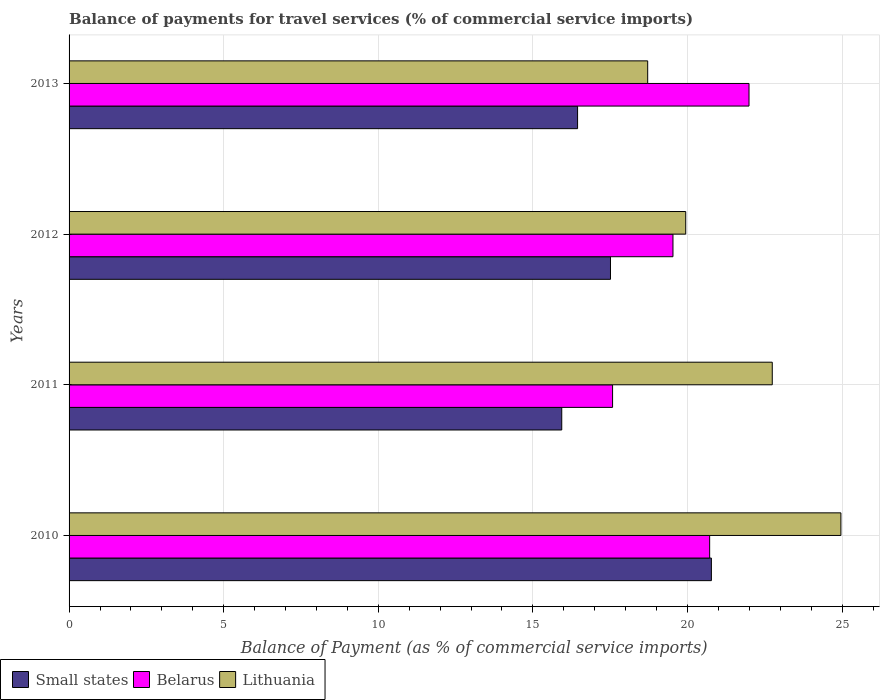How many different coloured bars are there?
Provide a short and direct response. 3. How many groups of bars are there?
Provide a succinct answer. 4. Are the number of bars on each tick of the Y-axis equal?
Provide a succinct answer. Yes. How many bars are there on the 4th tick from the bottom?
Your response must be concise. 3. What is the balance of payments for travel services in Lithuania in 2013?
Your answer should be very brief. 18.71. Across all years, what is the maximum balance of payments for travel services in Lithuania?
Ensure brevity in your answer.  24.96. Across all years, what is the minimum balance of payments for travel services in Belarus?
Ensure brevity in your answer.  17.58. What is the total balance of payments for travel services in Lithuania in the graph?
Provide a succinct answer. 86.36. What is the difference between the balance of payments for travel services in Small states in 2010 and that in 2013?
Your answer should be very brief. 4.33. What is the difference between the balance of payments for travel services in Small states in 2010 and the balance of payments for travel services in Lithuania in 2012?
Keep it short and to the point. 0.83. What is the average balance of payments for travel services in Small states per year?
Your answer should be compact. 17.66. In the year 2012, what is the difference between the balance of payments for travel services in Lithuania and balance of payments for travel services in Small states?
Offer a very short reply. 2.43. What is the ratio of the balance of payments for travel services in Lithuania in 2010 to that in 2012?
Your answer should be compact. 1.25. What is the difference between the highest and the second highest balance of payments for travel services in Lithuania?
Provide a succinct answer. 2.22. What is the difference between the highest and the lowest balance of payments for travel services in Lithuania?
Your response must be concise. 6.25. Is the sum of the balance of payments for travel services in Small states in 2010 and 2013 greater than the maximum balance of payments for travel services in Belarus across all years?
Your response must be concise. Yes. What does the 1st bar from the top in 2011 represents?
Ensure brevity in your answer.  Lithuania. What does the 2nd bar from the bottom in 2010 represents?
Keep it short and to the point. Belarus. Is it the case that in every year, the sum of the balance of payments for travel services in Small states and balance of payments for travel services in Lithuania is greater than the balance of payments for travel services in Belarus?
Offer a very short reply. Yes. How many bars are there?
Ensure brevity in your answer.  12. Are all the bars in the graph horizontal?
Your answer should be compact. Yes. How many years are there in the graph?
Offer a terse response. 4. What is the difference between two consecutive major ticks on the X-axis?
Make the answer very short. 5. Does the graph contain any zero values?
Give a very brief answer. No. How are the legend labels stacked?
Provide a succinct answer. Horizontal. What is the title of the graph?
Ensure brevity in your answer.  Balance of payments for travel services (% of commercial service imports). Does "Paraguay" appear as one of the legend labels in the graph?
Give a very brief answer. No. What is the label or title of the X-axis?
Offer a very short reply. Balance of Payment (as % of commercial service imports). What is the label or title of the Y-axis?
Provide a succinct answer. Years. What is the Balance of Payment (as % of commercial service imports) of Small states in 2010?
Give a very brief answer. 20.77. What is the Balance of Payment (as % of commercial service imports) of Belarus in 2010?
Ensure brevity in your answer.  20.72. What is the Balance of Payment (as % of commercial service imports) of Lithuania in 2010?
Provide a succinct answer. 24.96. What is the Balance of Payment (as % of commercial service imports) of Small states in 2011?
Make the answer very short. 15.93. What is the Balance of Payment (as % of commercial service imports) in Belarus in 2011?
Give a very brief answer. 17.58. What is the Balance of Payment (as % of commercial service imports) of Lithuania in 2011?
Make the answer very short. 22.74. What is the Balance of Payment (as % of commercial service imports) in Small states in 2012?
Offer a terse response. 17.51. What is the Balance of Payment (as % of commercial service imports) of Belarus in 2012?
Provide a succinct answer. 19.53. What is the Balance of Payment (as % of commercial service imports) of Lithuania in 2012?
Your response must be concise. 19.94. What is the Balance of Payment (as % of commercial service imports) of Small states in 2013?
Your response must be concise. 16.44. What is the Balance of Payment (as % of commercial service imports) of Belarus in 2013?
Offer a terse response. 21.99. What is the Balance of Payment (as % of commercial service imports) in Lithuania in 2013?
Give a very brief answer. 18.71. Across all years, what is the maximum Balance of Payment (as % of commercial service imports) of Small states?
Offer a very short reply. 20.77. Across all years, what is the maximum Balance of Payment (as % of commercial service imports) in Belarus?
Ensure brevity in your answer.  21.99. Across all years, what is the maximum Balance of Payment (as % of commercial service imports) of Lithuania?
Offer a terse response. 24.96. Across all years, what is the minimum Balance of Payment (as % of commercial service imports) of Small states?
Provide a short and direct response. 15.93. Across all years, what is the minimum Balance of Payment (as % of commercial service imports) of Belarus?
Your answer should be compact. 17.58. Across all years, what is the minimum Balance of Payment (as % of commercial service imports) of Lithuania?
Provide a short and direct response. 18.71. What is the total Balance of Payment (as % of commercial service imports) in Small states in the graph?
Make the answer very short. 70.66. What is the total Balance of Payment (as % of commercial service imports) in Belarus in the graph?
Offer a terse response. 79.81. What is the total Balance of Payment (as % of commercial service imports) of Lithuania in the graph?
Keep it short and to the point. 86.36. What is the difference between the Balance of Payment (as % of commercial service imports) of Small states in 2010 and that in 2011?
Your answer should be compact. 4.84. What is the difference between the Balance of Payment (as % of commercial service imports) of Belarus in 2010 and that in 2011?
Your response must be concise. 3.14. What is the difference between the Balance of Payment (as % of commercial service imports) of Lithuania in 2010 and that in 2011?
Your response must be concise. 2.22. What is the difference between the Balance of Payment (as % of commercial service imports) of Small states in 2010 and that in 2012?
Provide a short and direct response. 3.26. What is the difference between the Balance of Payment (as % of commercial service imports) of Belarus in 2010 and that in 2012?
Offer a terse response. 1.19. What is the difference between the Balance of Payment (as % of commercial service imports) of Lithuania in 2010 and that in 2012?
Provide a succinct answer. 5.02. What is the difference between the Balance of Payment (as % of commercial service imports) of Small states in 2010 and that in 2013?
Your answer should be very brief. 4.33. What is the difference between the Balance of Payment (as % of commercial service imports) of Belarus in 2010 and that in 2013?
Make the answer very short. -1.27. What is the difference between the Balance of Payment (as % of commercial service imports) of Lithuania in 2010 and that in 2013?
Your answer should be compact. 6.25. What is the difference between the Balance of Payment (as % of commercial service imports) in Small states in 2011 and that in 2012?
Keep it short and to the point. -1.58. What is the difference between the Balance of Payment (as % of commercial service imports) of Belarus in 2011 and that in 2012?
Make the answer very short. -1.95. What is the difference between the Balance of Payment (as % of commercial service imports) in Lithuania in 2011 and that in 2012?
Your response must be concise. 2.8. What is the difference between the Balance of Payment (as % of commercial service imports) in Small states in 2011 and that in 2013?
Make the answer very short. -0.51. What is the difference between the Balance of Payment (as % of commercial service imports) in Belarus in 2011 and that in 2013?
Keep it short and to the point. -4.41. What is the difference between the Balance of Payment (as % of commercial service imports) of Lithuania in 2011 and that in 2013?
Make the answer very short. 4.03. What is the difference between the Balance of Payment (as % of commercial service imports) of Small states in 2012 and that in 2013?
Ensure brevity in your answer.  1.06. What is the difference between the Balance of Payment (as % of commercial service imports) of Belarus in 2012 and that in 2013?
Ensure brevity in your answer.  -2.46. What is the difference between the Balance of Payment (as % of commercial service imports) of Lithuania in 2012 and that in 2013?
Your answer should be compact. 1.23. What is the difference between the Balance of Payment (as % of commercial service imports) of Small states in 2010 and the Balance of Payment (as % of commercial service imports) of Belarus in 2011?
Offer a terse response. 3.2. What is the difference between the Balance of Payment (as % of commercial service imports) of Small states in 2010 and the Balance of Payment (as % of commercial service imports) of Lithuania in 2011?
Provide a short and direct response. -1.97. What is the difference between the Balance of Payment (as % of commercial service imports) in Belarus in 2010 and the Balance of Payment (as % of commercial service imports) in Lithuania in 2011?
Ensure brevity in your answer.  -2.02. What is the difference between the Balance of Payment (as % of commercial service imports) of Small states in 2010 and the Balance of Payment (as % of commercial service imports) of Belarus in 2012?
Provide a short and direct response. 1.24. What is the difference between the Balance of Payment (as % of commercial service imports) in Small states in 2010 and the Balance of Payment (as % of commercial service imports) in Lithuania in 2012?
Give a very brief answer. 0.83. What is the difference between the Balance of Payment (as % of commercial service imports) of Belarus in 2010 and the Balance of Payment (as % of commercial service imports) of Lithuania in 2012?
Keep it short and to the point. 0.77. What is the difference between the Balance of Payment (as % of commercial service imports) of Small states in 2010 and the Balance of Payment (as % of commercial service imports) of Belarus in 2013?
Make the answer very short. -1.22. What is the difference between the Balance of Payment (as % of commercial service imports) of Small states in 2010 and the Balance of Payment (as % of commercial service imports) of Lithuania in 2013?
Make the answer very short. 2.06. What is the difference between the Balance of Payment (as % of commercial service imports) of Belarus in 2010 and the Balance of Payment (as % of commercial service imports) of Lithuania in 2013?
Offer a terse response. 2. What is the difference between the Balance of Payment (as % of commercial service imports) in Small states in 2011 and the Balance of Payment (as % of commercial service imports) in Belarus in 2012?
Your answer should be very brief. -3.6. What is the difference between the Balance of Payment (as % of commercial service imports) in Small states in 2011 and the Balance of Payment (as % of commercial service imports) in Lithuania in 2012?
Make the answer very short. -4.01. What is the difference between the Balance of Payment (as % of commercial service imports) of Belarus in 2011 and the Balance of Payment (as % of commercial service imports) of Lithuania in 2012?
Your answer should be very brief. -2.37. What is the difference between the Balance of Payment (as % of commercial service imports) in Small states in 2011 and the Balance of Payment (as % of commercial service imports) in Belarus in 2013?
Provide a succinct answer. -6.06. What is the difference between the Balance of Payment (as % of commercial service imports) in Small states in 2011 and the Balance of Payment (as % of commercial service imports) in Lithuania in 2013?
Make the answer very short. -2.78. What is the difference between the Balance of Payment (as % of commercial service imports) in Belarus in 2011 and the Balance of Payment (as % of commercial service imports) in Lithuania in 2013?
Offer a very short reply. -1.14. What is the difference between the Balance of Payment (as % of commercial service imports) of Small states in 2012 and the Balance of Payment (as % of commercial service imports) of Belarus in 2013?
Provide a succinct answer. -4.48. What is the difference between the Balance of Payment (as % of commercial service imports) of Small states in 2012 and the Balance of Payment (as % of commercial service imports) of Lithuania in 2013?
Give a very brief answer. -1.2. What is the difference between the Balance of Payment (as % of commercial service imports) of Belarus in 2012 and the Balance of Payment (as % of commercial service imports) of Lithuania in 2013?
Offer a very short reply. 0.82. What is the average Balance of Payment (as % of commercial service imports) of Small states per year?
Your answer should be compact. 17.66. What is the average Balance of Payment (as % of commercial service imports) in Belarus per year?
Ensure brevity in your answer.  19.95. What is the average Balance of Payment (as % of commercial service imports) in Lithuania per year?
Your answer should be very brief. 21.59. In the year 2010, what is the difference between the Balance of Payment (as % of commercial service imports) in Small states and Balance of Payment (as % of commercial service imports) in Belarus?
Your answer should be compact. 0.06. In the year 2010, what is the difference between the Balance of Payment (as % of commercial service imports) in Small states and Balance of Payment (as % of commercial service imports) in Lithuania?
Keep it short and to the point. -4.19. In the year 2010, what is the difference between the Balance of Payment (as % of commercial service imports) in Belarus and Balance of Payment (as % of commercial service imports) in Lithuania?
Your answer should be very brief. -4.24. In the year 2011, what is the difference between the Balance of Payment (as % of commercial service imports) in Small states and Balance of Payment (as % of commercial service imports) in Belarus?
Ensure brevity in your answer.  -1.64. In the year 2011, what is the difference between the Balance of Payment (as % of commercial service imports) of Small states and Balance of Payment (as % of commercial service imports) of Lithuania?
Ensure brevity in your answer.  -6.81. In the year 2011, what is the difference between the Balance of Payment (as % of commercial service imports) in Belarus and Balance of Payment (as % of commercial service imports) in Lithuania?
Provide a short and direct response. -5.16. In the year 2012, what is the difference between the Balance of Payment (as % of commercial service imports) in Small states and Balance of Payment (as % of commercial service imports) in Belarus?
Keep it short and to the point. -2.02. In the year 2012, what is the difference between the Balance of Payment (as % of commercial service imports) of Small states and Balance of Payment (as % of commercial service imports) of Lithuania?
Your answer should be compact. -2.43. In the year 2012, what is the difference between the Balance of Payment (as % of commercial service imports) in Belarus and Balance of Payment (as % of commercial service imports) in Lithuania?
Your response must be concise. -0.41. In the year 2013, what is the difference between the Balance of Payment (as % of commercial service imports) of Small states and Balance of Payment (as % of commercial service imports) of Belarus?
Provide a succinct answer. -5.54. In the year 2013, what is the difference between the Balance of Payment (as % of commercial service imports) of Small states and Balance of Payment (as % of commercial service imports) of Lithuania?
Give a very brief answer. -2.27. In the year 2013, what is the difference between the Balance of Payment (as % of commercial service imports) in Belarus and Balance of Payment (as % of commercial service imports) in Lithuania?
Give a very brief answer. 3.28. What is the ratio of the Balance of Payment (as % of commercial service imports) of Small states in 2010 to that in 2011?
Offer a terse response. 1.3. What is the ratio of the Balance of Payment (as % of commercial service imports) of Belarus in 2010 to that in 2011?
Offer a terse response. 1.18. What is the ratio of the Balance of Payment (as % of commercial service imports) in Lithuania in 2010 to that in 2011?
Make the answer very short. 1.1. What is the ratio of the Balance of Payment (as % of commercial service imports) in Small states in 2010 to that in 2012?
Make the answer very short. 1.19. What is the ratio of the Balance of Payment (as % of commercial service imports) of Belarus in 2010 to that in 2012?
Ensure brevity in your answer.  1.06. What is the ratio of the Balance of Payment (as % of commercial service imports) in Lithuania in 2010 to that in 2012?
Your response must be concise. 1.25. What is the ratio of the Balance of Payment (as % of commercial service imports) of Small states in 2010 to that in 2013?
Offer a very short reply. 1.26. What is the ratio of the Balance of Payment (as % of commercial service imports) in Belarus in 2010 to that in 2013?
Provide a short and direct response. 0.94. What is the ratio of the Balance of Payment (as % of commercial service imports) in Lithuania in 2010 to that in 2013?
Ensure brevity in your answer.  1.33. What is the ratio of the Balance of Payment (as % of commercial service imports) of Small states in 2011 to that in 2012?
Give a very brief answer. 0.91. What is the ratio of the Balance of Payment (as % of commercial service imports) in Lithuania in 2011 to that in 2012?
Provide a short and direct response. 1.14. What is the ratio of the Balance of Payment (as % of commercial service imports) in Small states in 2011 to that in 2013?
Your answer should be compact. 0.97. What is the ratio of the Balance of Payment (as % of commercial service imports) of Belarus in 2011 to that in 2013?
Provide a short and direct response. 0.8. What is the ratio of the Balance of Payment (as % of commercial service imports) in Lithuania in 2011 to that in 2013?
Provide a succinct answer. 1.22. What is the ratio of the Balance of Payment (as % of commercial service imports) in Small states in 2012 to that in 2013?
Your answer should be very brief. 1.06. What is the ratio of the Balance of Payment (as % of commercial service imports) in Belarus in 2012 to that in 2013?
Your answer should be very brief. 0.89. What is the ratio of the Balance of Payment (as % of commercial service imports) in Lithuania in 2012 to that in 2013?
Provide a succinct answer. 1.07. What is the difference between the highest and the second highest Balance of Payment (as % of commercial service imports) in Small states?
Make the answer very short. 3.26. What is the difference between the highest and the second highest Balance of Payment (as % of commercial service imports) of Belarus?
Give a very brief answer. 1.27. What is the difference between the highest and the second highest Balance of Payment (as % of commercial service imports) of Lithuania?
Give a very brief answer. 2.22. What is the difference between the highest and the lowest Balance of Payment (as % of commercial service imports) in Small states?
Your answer should be very brief. 4.84. What is the difference between the highest and the lowest Balance of Payment (as % of commercial service imports) in Belarus?
Your answer should be very brief. 4.41. What is the difference between the highest and the lowest Balance of Payment (as % of commercial service imports) of Lithuania?
Offer a terse response. 6.25. 